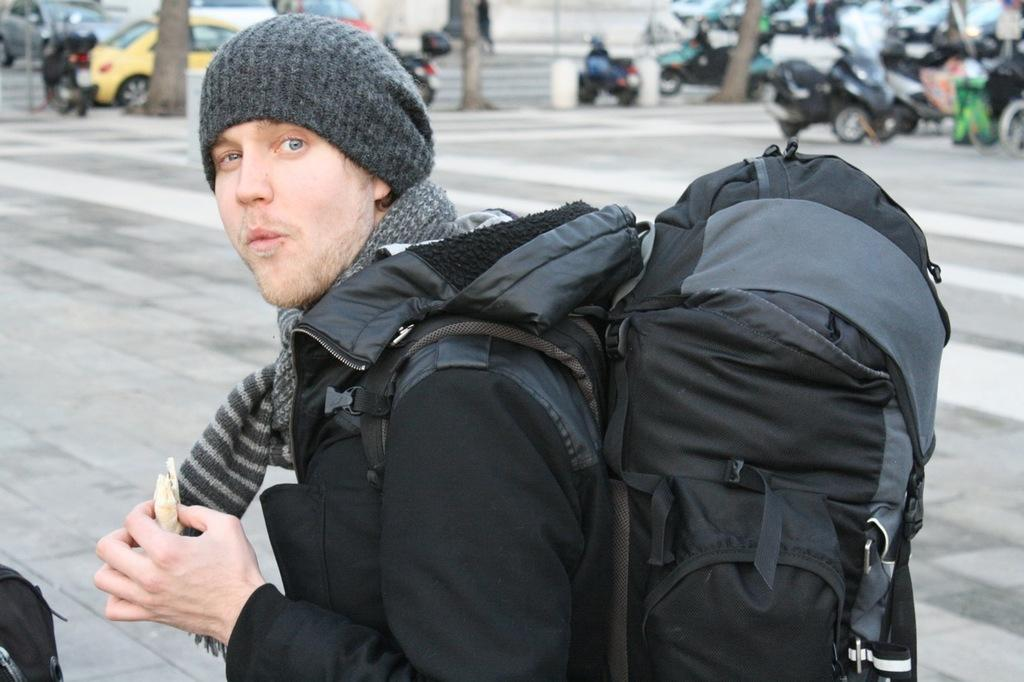What is the person in the image wearing? The person is wearing a black shirt in the image. What is the person carrying in the image? The person is carrying a backpack in the image. What can be seen in the background of the image? There are many vehicles in the background of the image. Can you see the seashore in the image? No, there is no seashore visible in the image. Is there a cannon present in the image? No, there is no cannon present in the image. 